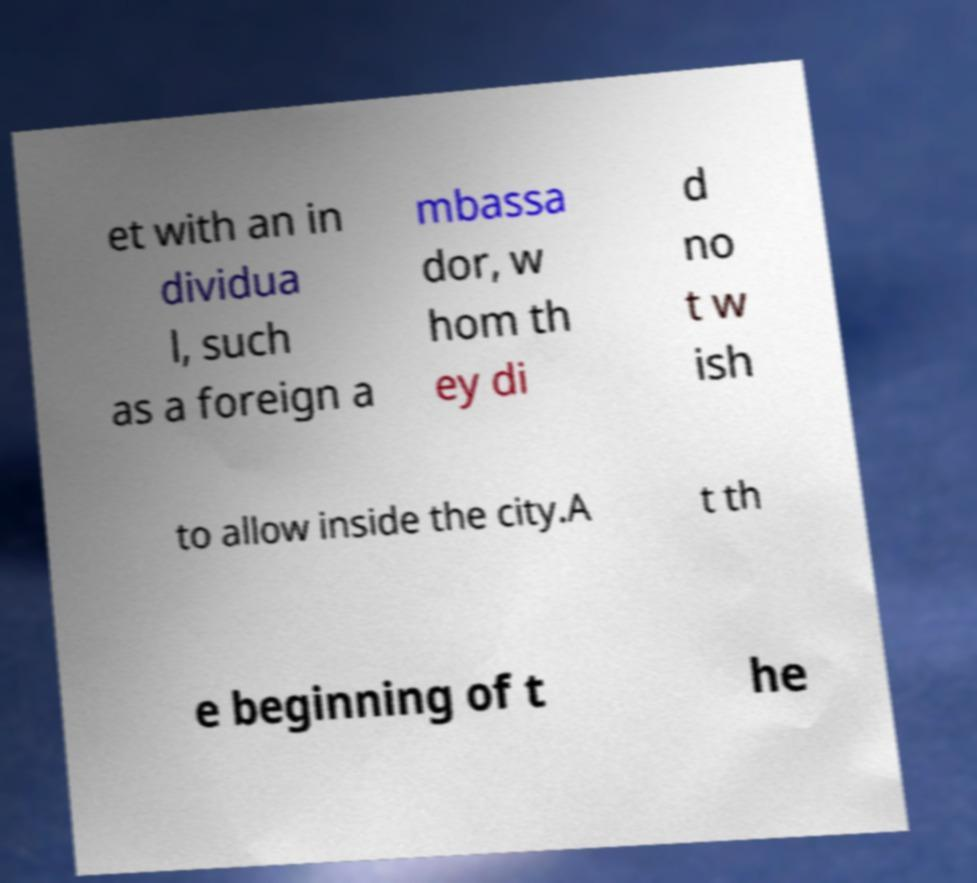I need the written content from this picture converted into text. Can you do that? et with an in dividua l, such as a foreign a mbassa dor, w hom th ey di d no t w ish to allow inside the city.A t th e beginning of t he 